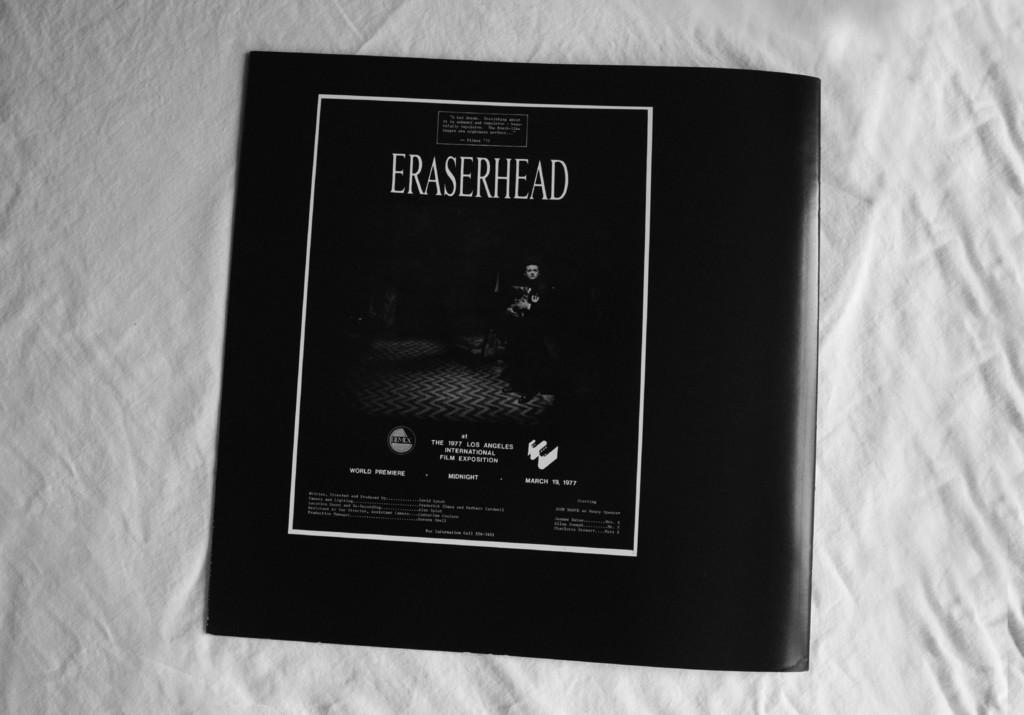<image>
Share a concise interpretation of the image provided. The front of some sort of packaging that reads ERASERHEAD. 